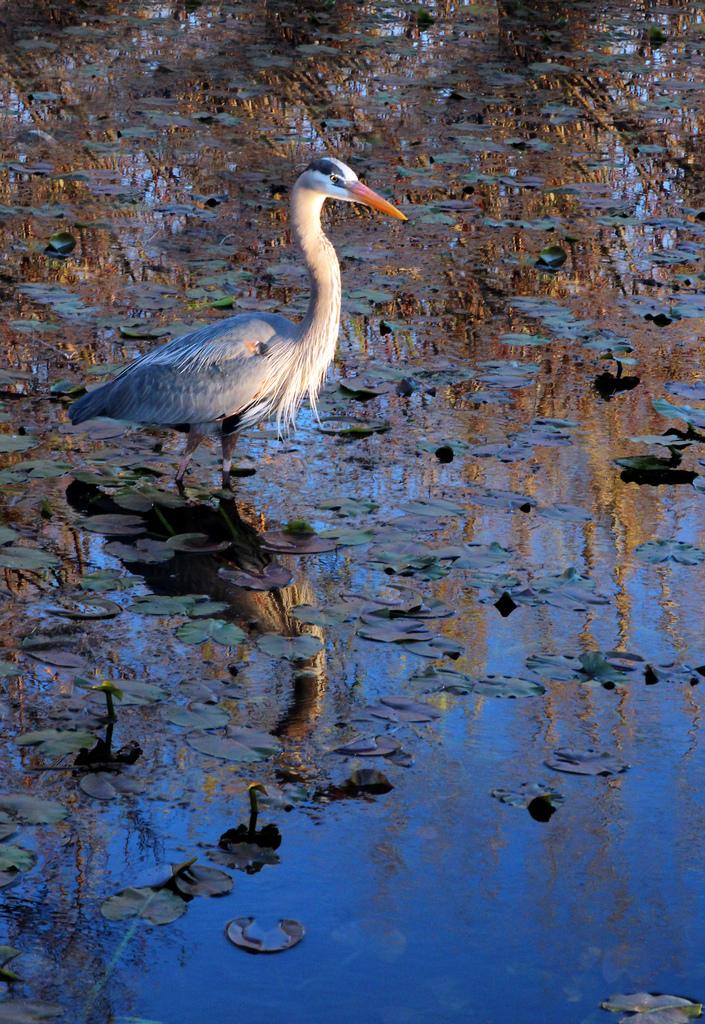What is the main subject of the image? There is a crane in the image. Where is the crane located? The crane is in the water. What else can be seen in the image besides the crane? There are leaves visible in the image. How quiet is the bread in the image? There is no bread present in the image, so it cannot be determined how quiet it might be. 